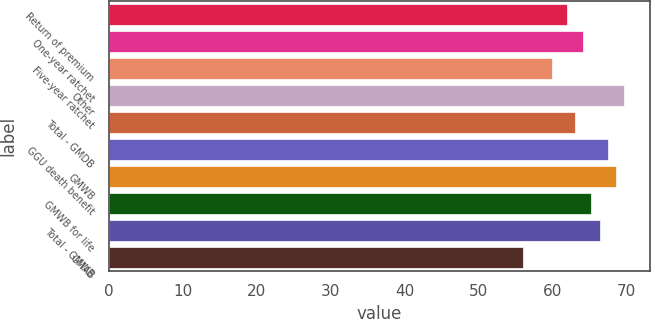Convert chart to OTSL. <chart><loc_0><loc_0><loc_500><loc_500><bar_chart><fcel>Return of premium<fcel>One-year ratchet<fcel>Five-year ratchet<fcel>Other<fcel>Total - GMDB<fcel>GGU death benefit<fcel>GMWB<fcel>GMWB for life<fcel>Total - GMWB<fcel>GMAB<nl><fcel>62<fcel>64.2<fcel>60<fcel>69.7<fcel>63.1<fcel>67.5<fcel>68.6<fcel>65.3<fcel>66.4<fcel>56<nl></chart> 